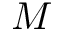Convert formula to latex. <formula><loc_0><loc_0><loc_500><loc_500>M</formula> 